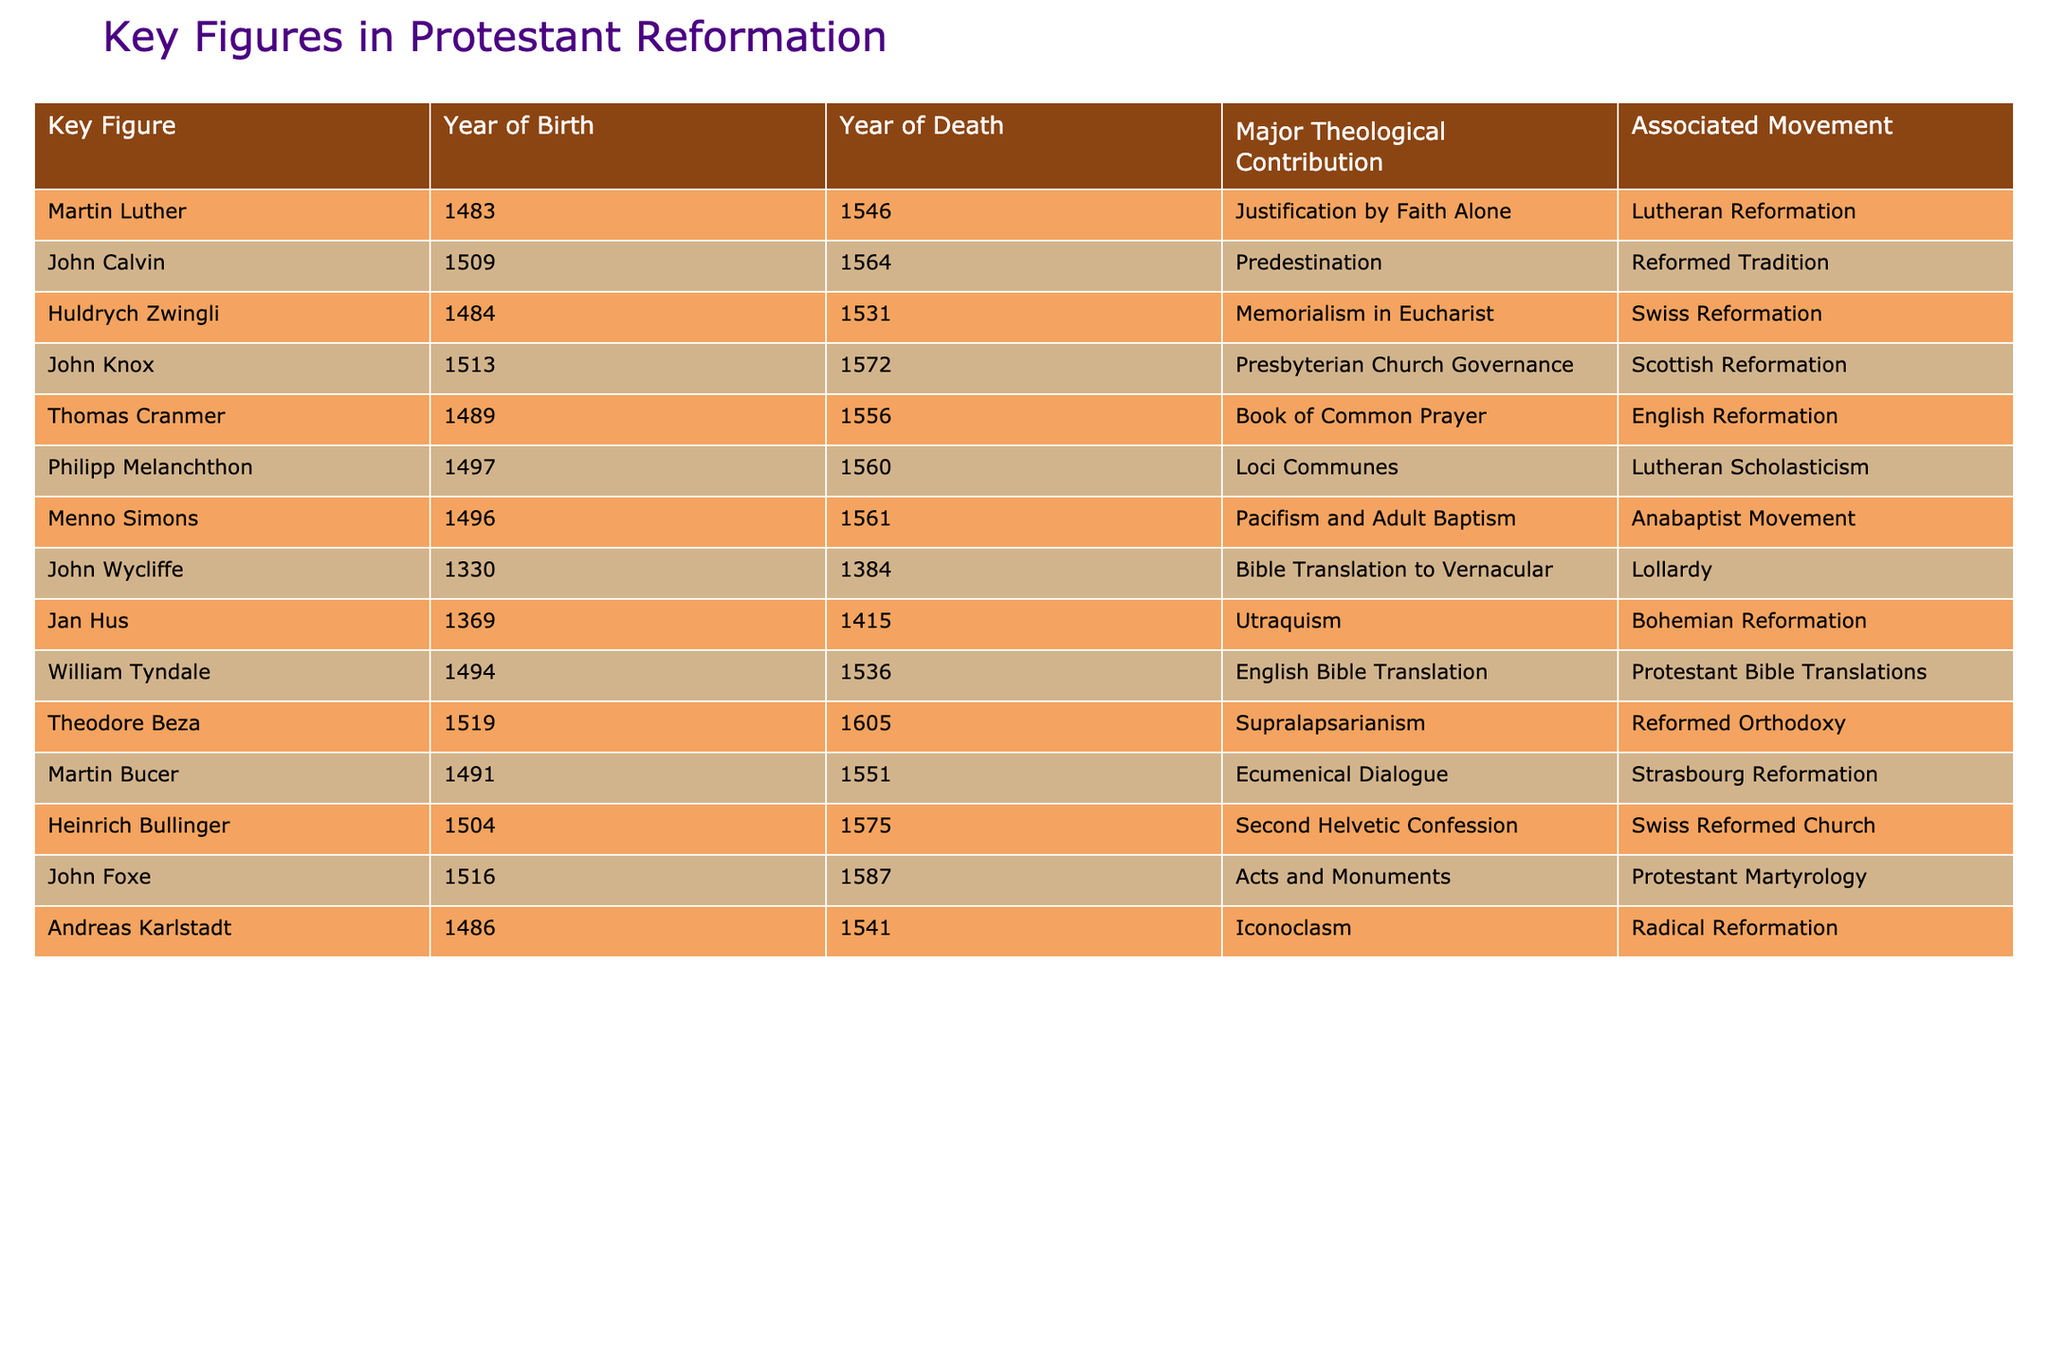What year was Martin Luther born? Martin Luther is listed in the table with the Year of Birth column showing 1483.
Answer: 1483 Who contributed to the development of the Presbyterian Church Governance? The table indicates that John Knox is associated with the Presbyterian Church Governance as his major theological contribution.
Answer: John Knox How many key figures were born before 1500? By reviewing the Year of Birth column, the figures born before 1500 are John Wycliffe (1330), Jan Hus (1369), Huldrych Zwingli (1484), Martin Luther (1483), and Thomas Cranmer (1489), totaling 5 figures.
Answer: 5 Which key figure’s contribution is related to adult baptism? The table shows that Menno Simons is the key figure associated with Pacifism and Adult Baptism.
Answer: Menno Simons Is William Tyndale associated with the Reformed Tradition? The table indicates that William Tyndale's contribution is related to English Bible Translation, with no link to the Reformed Tradition noted; therefore, the answer is no.
Answer: No Who had the earliest birth year among the listed figures? By looking at the Year of Birth column, John Wycliffe has the earliest birth year of 1330 compared to the others.
Answer: John Wycliffe What is the major theological contribution of John Calvin? The table lists John Calvin's major theological contribution as Predestination.
Answer: Predestination How many reformers were born in the 16th century? The figures born in the 16th century include John Calvin (1509), John Knox (1513), Theodore Beza (1519), Martin Bucer (1491), and Heinrich Bullinger (1504), totaling 6 reformers.
Answer: 6 Which theological movement is associated with Huldrych Zwingli? The table indicates that Huldrych Zwingli is associated with the Swiss Reformation movement.
Answer: Swiss Reformation Identify the individuals associated with the Protestant Bible Translations movement. The table explicitly states that William Tyndale is the key figure linked to the Protestant Bible Translations movement.
Answer: William Tyndale What is the difference between the birth years of Martin Luther and John Calvin? Martin Luther was born in 1483 and John Calvin was born in 1509. To find the difference, subtract 1483 from 1509, which equals 26 years.
Answer: 26 years 